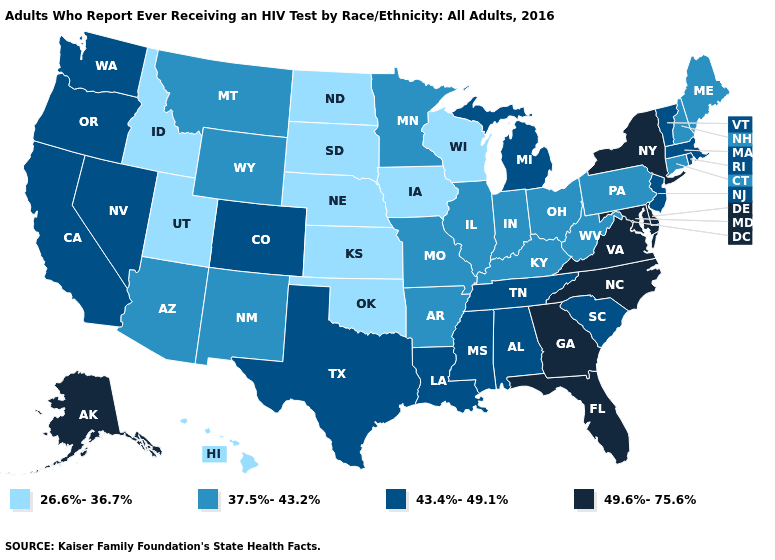What is the highest value in states that border Oregon?
Give a very brief answer. 43.4%-49.1%. What is the highest value in states that border Utah?
Write a very short answer. 43.4%-49.1%. Does Florida have the same value as New Hampshire?
Give a very brief answer. No. Is the legend a continuous bar?
Short answer required. No. Name the states that have a value in the range 37.5%-43.2%?
Concise answer only. Arizona, Arkansas, Connecticut, Illinois, Indiana, Kentucky, Maine, Minnesota, Missouri, Montana, New Hampshire, New Mexico, Ohio, Pennsylvania, West Virginia, Wyoming. What is the value of New Jersey?
Quick response, please. 43.4%-49.1%. What is the lowest value in the MidWest?
Quick response, please. 26.6%-36.7%. What is the value of Massachusetts?
Quick response, please. 43.4%-49.1%. What is the lowest value in the USA?
Keep it brief. 26.6%-36.7%. Among the states that border Wisconsin , which have the highest value?
Give a very brief answer. Michigan. Does Iowa have the lowest value in the MidWest?
Keep it brief. Yes. Name the states that have a value in the range 43.4%-49.1%?
Concise answer only. Alabama, California, Colorado, Louisiana, Massachusetts, Michigan, Mississippi, Nevada, New Jersey, Oregon, Rhode Island, South Carolina, Tennessee, Texas, Vermont, Washington. What is the lowest value in the USA?
Write a very short answer. 26.6%-36.7%. Does North Carolina have the highest value in the South?
Concise answer only. Yes. Name the states that have a value in the range 49.6%-75.6%?
Be succinct. Alaska, Delaware, Florida, Georgia, Maryland, New York, North Carolina, Virginia. 